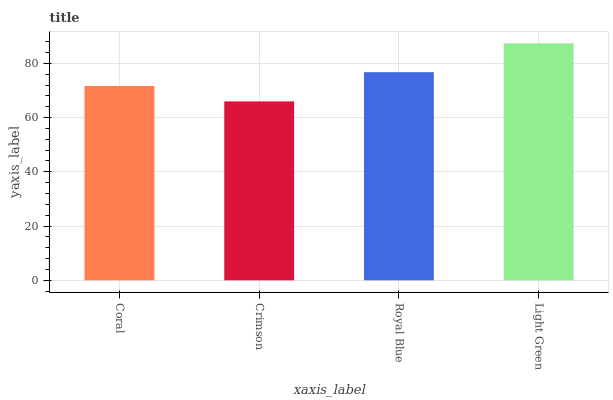Is Crimson the minimum?
Answer yes or no. Yes. Is Light Green the maximum?
Answer yes or no. Yes. Is Royal Blue the minimum?
Answer yes or no. No. Is Royal Blue the maximum?
Answer yes or no. No. Is Royal Blue greater than Crimson?
Answer yes or no. Yes. Is Crimson less than Royal Blue?
Answer yes or no. Yes. Is Crimson greater than Royal Blue?
Answer yes or no. No. Is Royal Blue less than Crimson?
Answer yes or no. No. Is Royal Blue the high median?
Answer yes or no. Yes. Is Coral the low median?
Answer yes or no. Yes. Is Light Green the high median?
Answer yes or no. No. Is Light Green the low median?
Answer yes or no. No. 